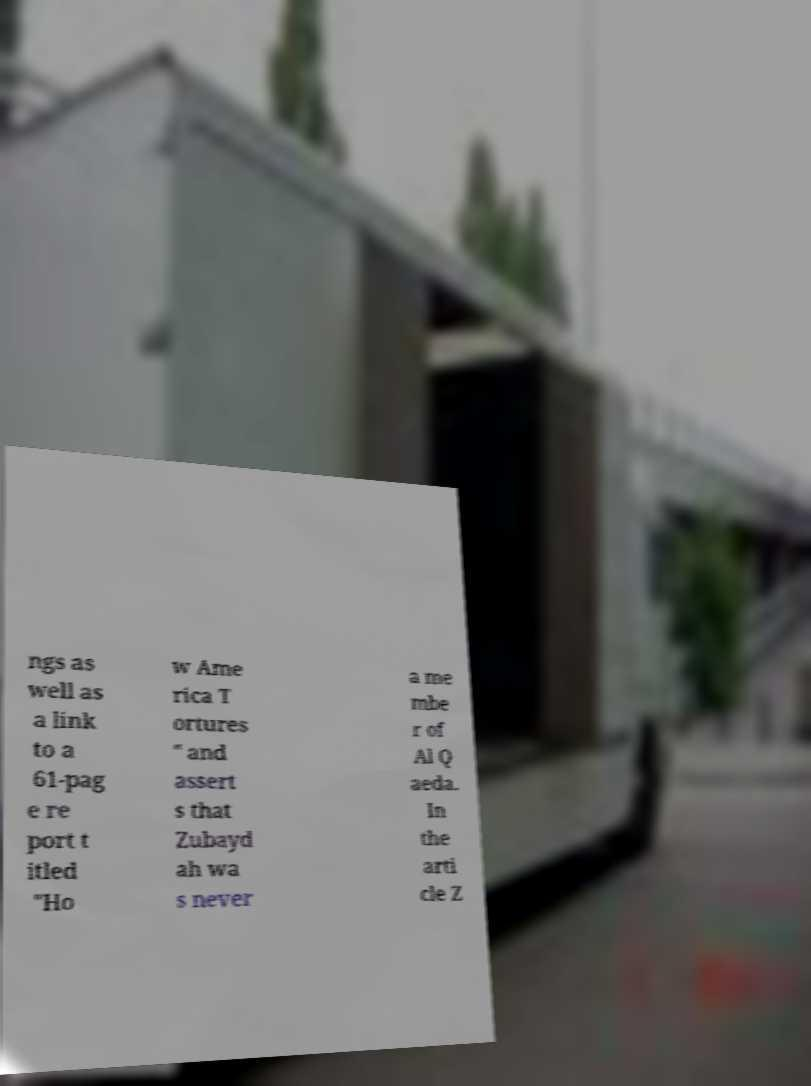Can you accurately transcribe the text from the provided image for me? ngs as well as a link to a 61-pag e re port t itled "Ho w Ame rica T ortures " and assert s that Zubayd ah wa s never a me mbe r of Al Q aeda. In the arti cle Z 